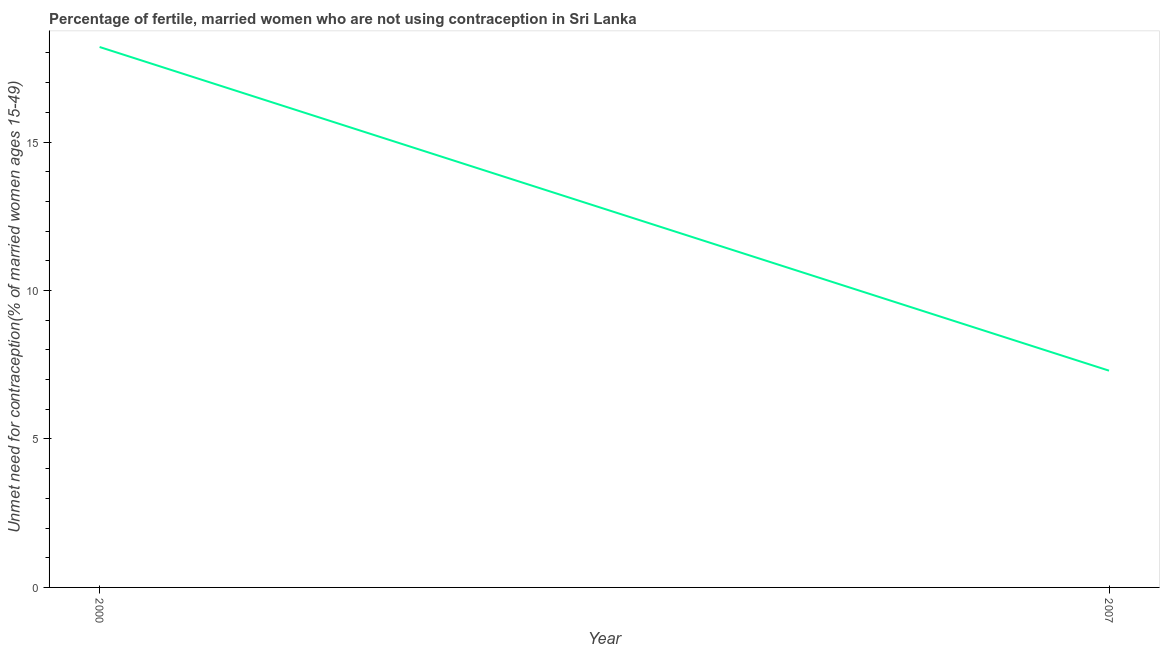What is the number of married women who are not using contraception in 2000?
Your response must be concise. 18.2. Across all years, what is the maximum number of married women who are not using contraception?
Offer a terse response. 18.2. In which year was the number of married women who are not using contraception maximum?
Ensure brevity in your answer.  2000. What is the difference between the number of married women who are not using contraception in 2000 and 2007?
Give a very brief answer. 10.9. What is the average number of married women who are not using contraception per year?
Offer a terse response. 12.75. What is the median number of married women who are not using contraception?
Make the answer very short. 12.75. In how many years, is the number of married women who are not using contraception greater than 4 %?
Your response must be concise. 2. Do a majority of the years between 2000 and 2007 (inclusive) have number of married women who are not using contraception greater than 17 %?
Offer a very short reply. No. What is the ratio of the number of married women who are not using contraception in 2000 to that in 2007?
Give a very brief answer. 2.49. In how many years, is the number of married women who are not using contraception greater than the average number of married women who are not using contraception taken over all years?
Offer a terse response. 1. Does the number of married women who are not using contraception monotonically increase over the years?
Your answer should be compact. No. How many lines are there?
Offer a terse response. 1. How many years are there in the graph?
Give a very brief answer. 2. Are the values on the major ticks of Y-axis written in scientific E-notation?
Keep it short and to the point. No. Does the graph contain grids?
Make the answer very short. No. What is the title of the graph?
Give a very brief answer. Percentage of fertile, married women who are not using contraception in Sri Lanka. What is the label or title of the Y-axis?
Offer a terse response.  Unmet need for contraception(% of married women ages 15-49). What is the difference between the  Unmet need for contraception(% of married women ages 15-49) in 2000 and 2007?
Offer a very short reply. 10.9. What is the ratio of the  Unmet need for contraception(% of married women ages 15-49) in 2000 to that in 2007?
Make the answer very short. 2.49. 